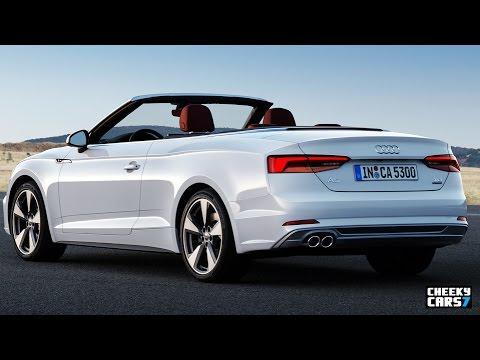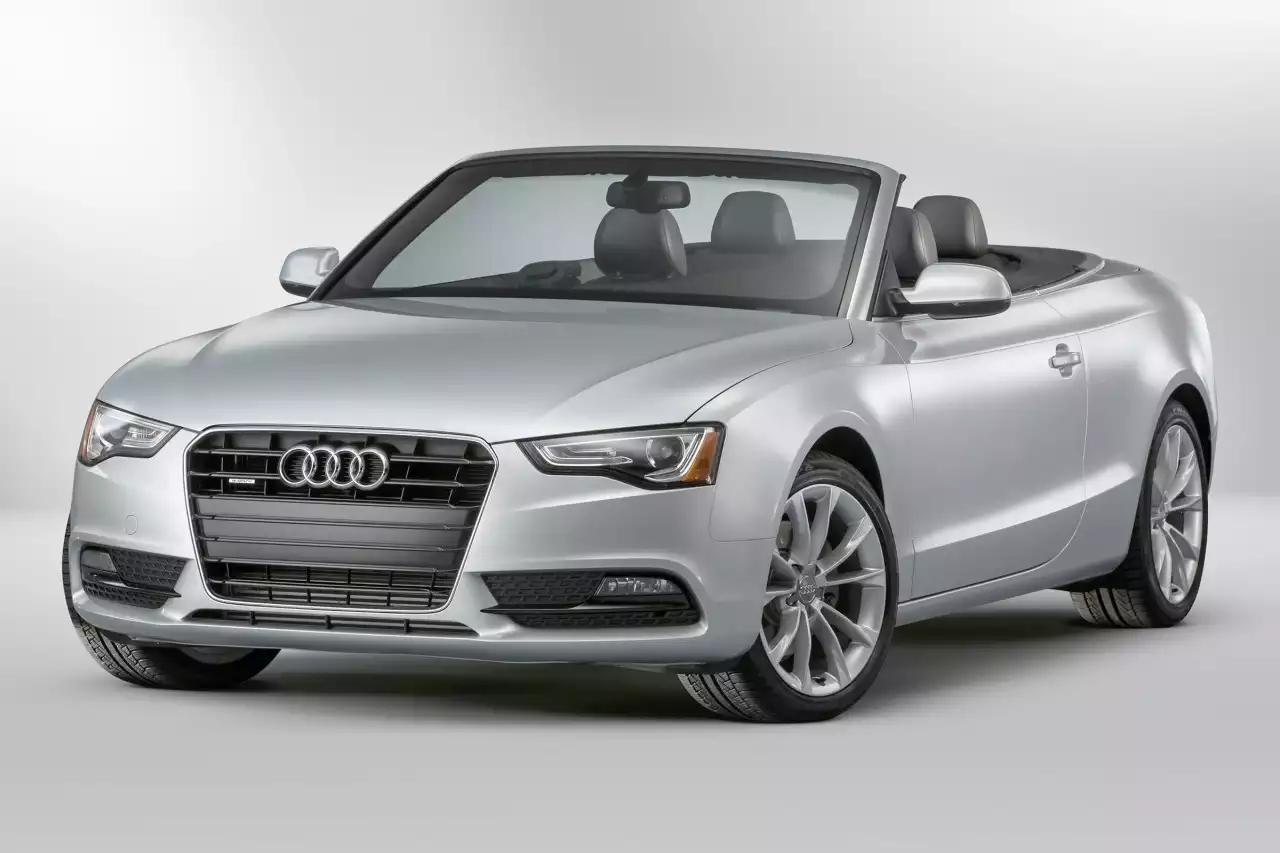The first image is the image on the left, the second image is the image on the right. Considering the images on both sides, is "The combined images include a topless white convertible with its rear to the camera moving leftward, and a topless convertible facing forward." valid? Answer yes or no. Yes. The first image is the image on the left, the second image is the image on the right. Evaluate the accuracy of this statement regarding the images: "There is at least one car facing towards the right side.". Is it true? Answer yes or no. No. 